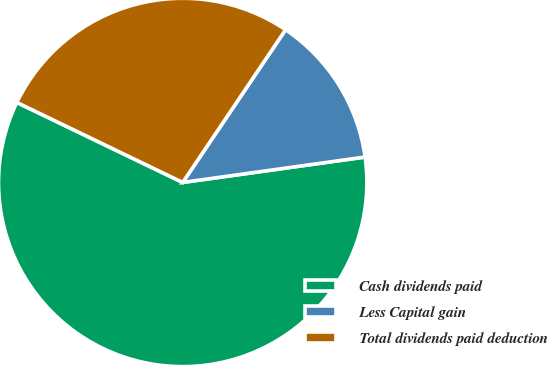Convert chart. <chart><loc_0><loc_0><loc_500><loc_500><pie_chart><fcel>Cash dividends paid<fcel>Less Capital gain<fcel>Total dividends paid deduction<nl><fcel>59.36%<fcel>13.36%<fcel>27.28%<nl></chart> 